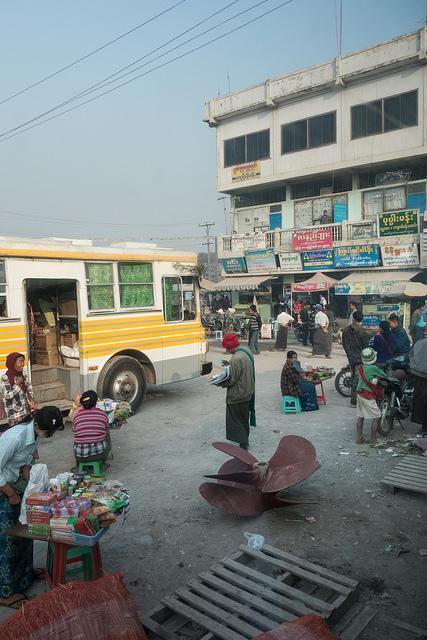How many people can you see?
Give a very brief answer. 4. How many keyboards are there?
Give a very brief answer. 0. 